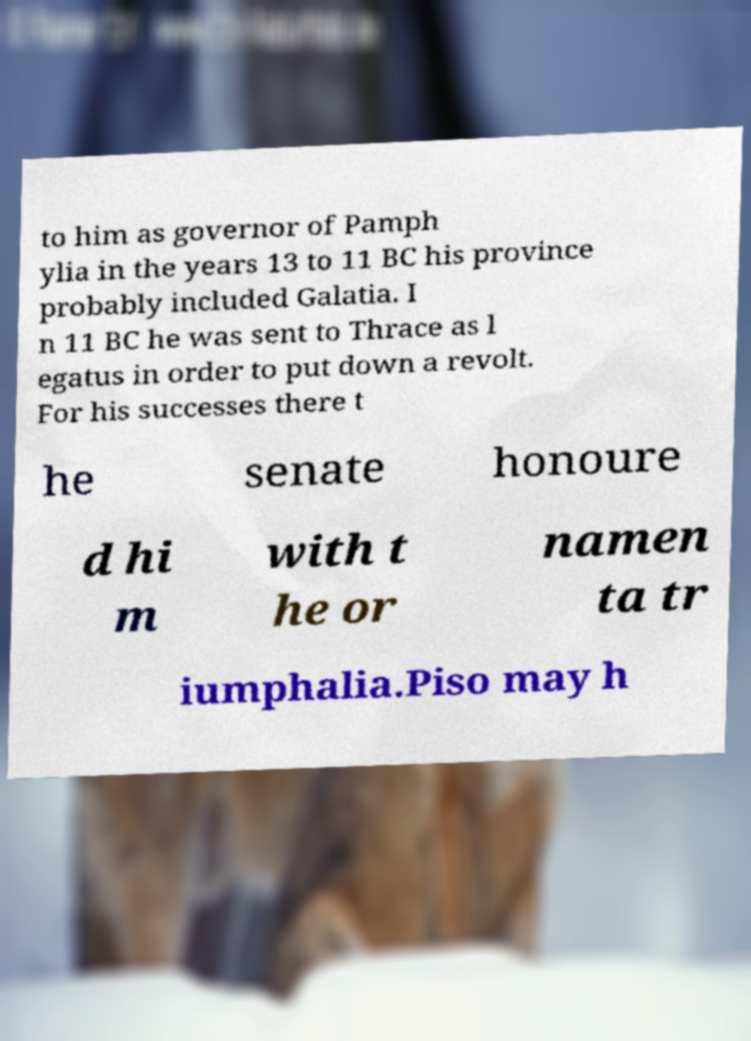What messages or text are displayed in this image? I need them in a readable, typed format. to him as governor of Pamph ylia in the years 13 to 11 BC his province probably included Galatia. I n 11 BC he was sent to Thrace as l egatus in order to put down a revolt. For his successes there t he senate honoure d hi m with t he or namen ta tr iumphalia.Piso may h 